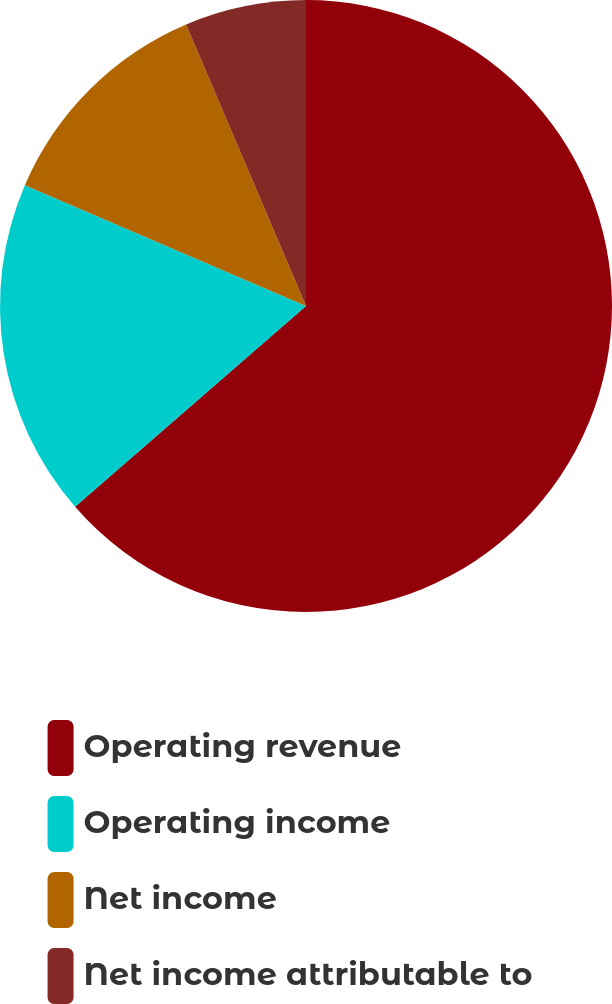Convert chart. <chart><loc_0><loc_0><loc_500><loc_500><pie_chart><fcel>Operating revenue<fcel>Operating income<fcel>Net income<fcel>Net income attributable to<nl><fcel>63.61%<fcel>17.85%<fcel>12.13%<fcel>6.41%<nl></chart> 